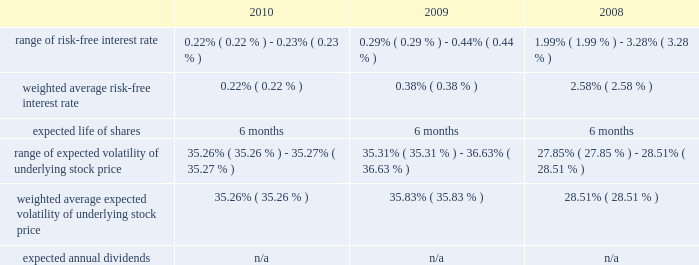American tower corporation and subsidiaries notes to consolidated financial statements as of december 31 , 2010 , total unrecognized compensation expense related to unvested restricted stock units granted under the 2007 plan was $ 57.5 million and is expected to be recognized over a weighted average period of approximately two years .
Employee stock purchase plan 2014the company maintains an employee stock purchase plan ( 201cespp 201d ) for all eligible employees .
Under the espp , shares of the company 2019s common stock may be purchased during bi-annual offering periods at 85% ( 85 % ) of the lower of the fair market value on the first or the last day of each offering period .
Employees may purchase shares having a value not exceeding 15% ( 15 % ) of their gross compensation during an offering period and may not purchase more than $ 25000 worth of stock in a calendar year ( based on market values at the beginning of each offering period ) .
The offering periods run from june 1 through november 30 and from december 1 through may 31 of each year .
During the 2010 , 2009 and 2008 offering periods employees purchased 75354 , 77509 and 55764 shares , respectively , at weighted average prices per share of $ 34.16 , $ 23.91 and $ 30.08 , respectively .
The fair value of the espp offerings is estimated on the offering period commencement date using a black-scholes pricing model with the expense recognized over the expected life , which is the six month offering period over which employees accumulate payroll deductions to purchase the company 2019s common stock .
The weighted average fair value for the espp shares purchased during 2010 , 2009 and 2008 was $ 9.43 , $ 6.65 and $ 7.89 , respectively .
At december 31 , 2010 , 8.7 million shares remain reserved for future issuance under the plan .
Key assumptions used to apply this pricing model for the years ended december 31 , are as follows: .
13 .
Stockholders 2019 equity warrants 2014in august 2005 , the company completed its merger with spectrasite , inc .
And assumed outstanding warrants to purchase shares of spectrasite , inc .
Common stock .
As of the merger completion date , each warrant was exercisable for two shares of spectrasite , inc .
Common stock at an exercise price of $ 32 per warrant .
Upon completion of the merger , each warrant to purchase shares of spectrasite , inc .
Common stock automatically converted into a warrant to purchase shares of the company 2019s common stock , such that upon exercise of each warrant , the holder has a right to receive 3.575 shares of the company 2019s common stock in lieu of each share of spectrasite , inc .
Common stock that would have been receivable under each assumed warrant prior to the merger .
Upon completion of the company 2019s merger with spectrasite , inc. , these warrants were exercisable for approximately 6.8 million shares of common stock .
Of these warrants , warrants to purchase approximately none and 1.7 million shares of common stock remained outstanding as of december 31 , 2010 and 2009 , respectively .
These warrants expired on february 10 , 2010 .
Stock repurchase program 2014during the year ended december 31 , 2010 , the company repurchased an aggregate of approximately 9.3 million shares of its common stock for an aggregate of $ 420.8 million , including commissions and fees , of which $ 418.6 million was paid in cash prior to december 31 , 2010 and $ 2.2 million was included in accounts payable and accrued expenses in the accompanying consolidated balance sheet as of december 31 , 2010 , pursuant to its publicly announced stock repurchase program , as described below. .
What is the total cash received from shares purchased from employees during 2010 , in millions? 
Computations: (75354 * 34.16)
Answer: 2574092.64. 